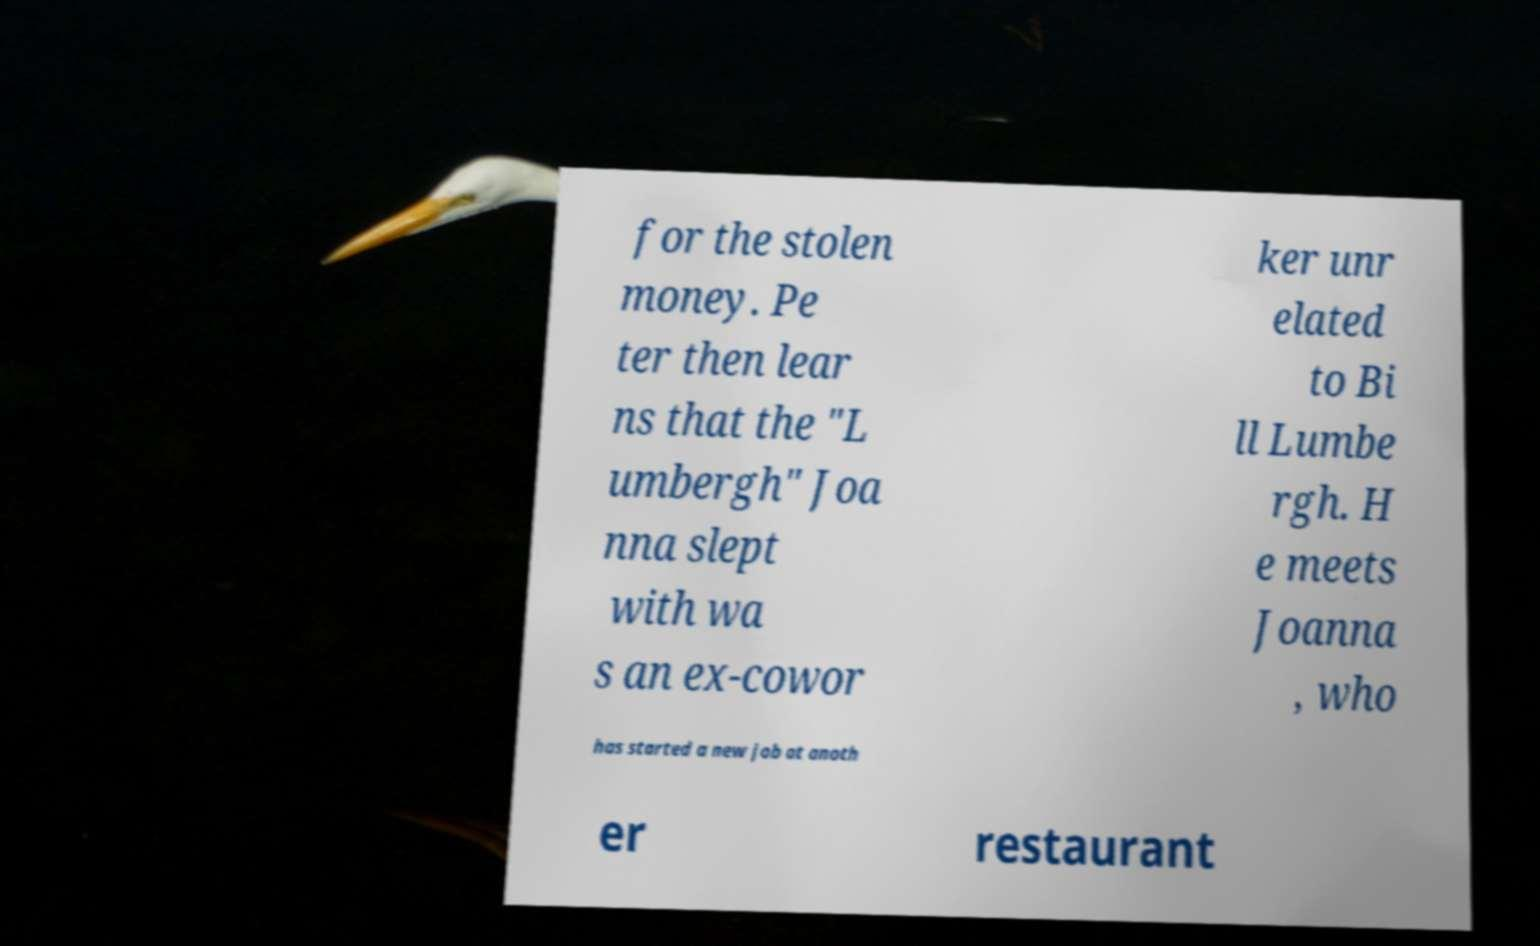Please read and relay the text visible in this image. What does it say? for the stolen money. Pe ter then lear ns that the "L umbergh" Joa nna slept with wa s an ex-cowor ker unr elated to Bi ll Lumbe rgh. H e meets Joanna , who has started a new job at anoth er restaurant 